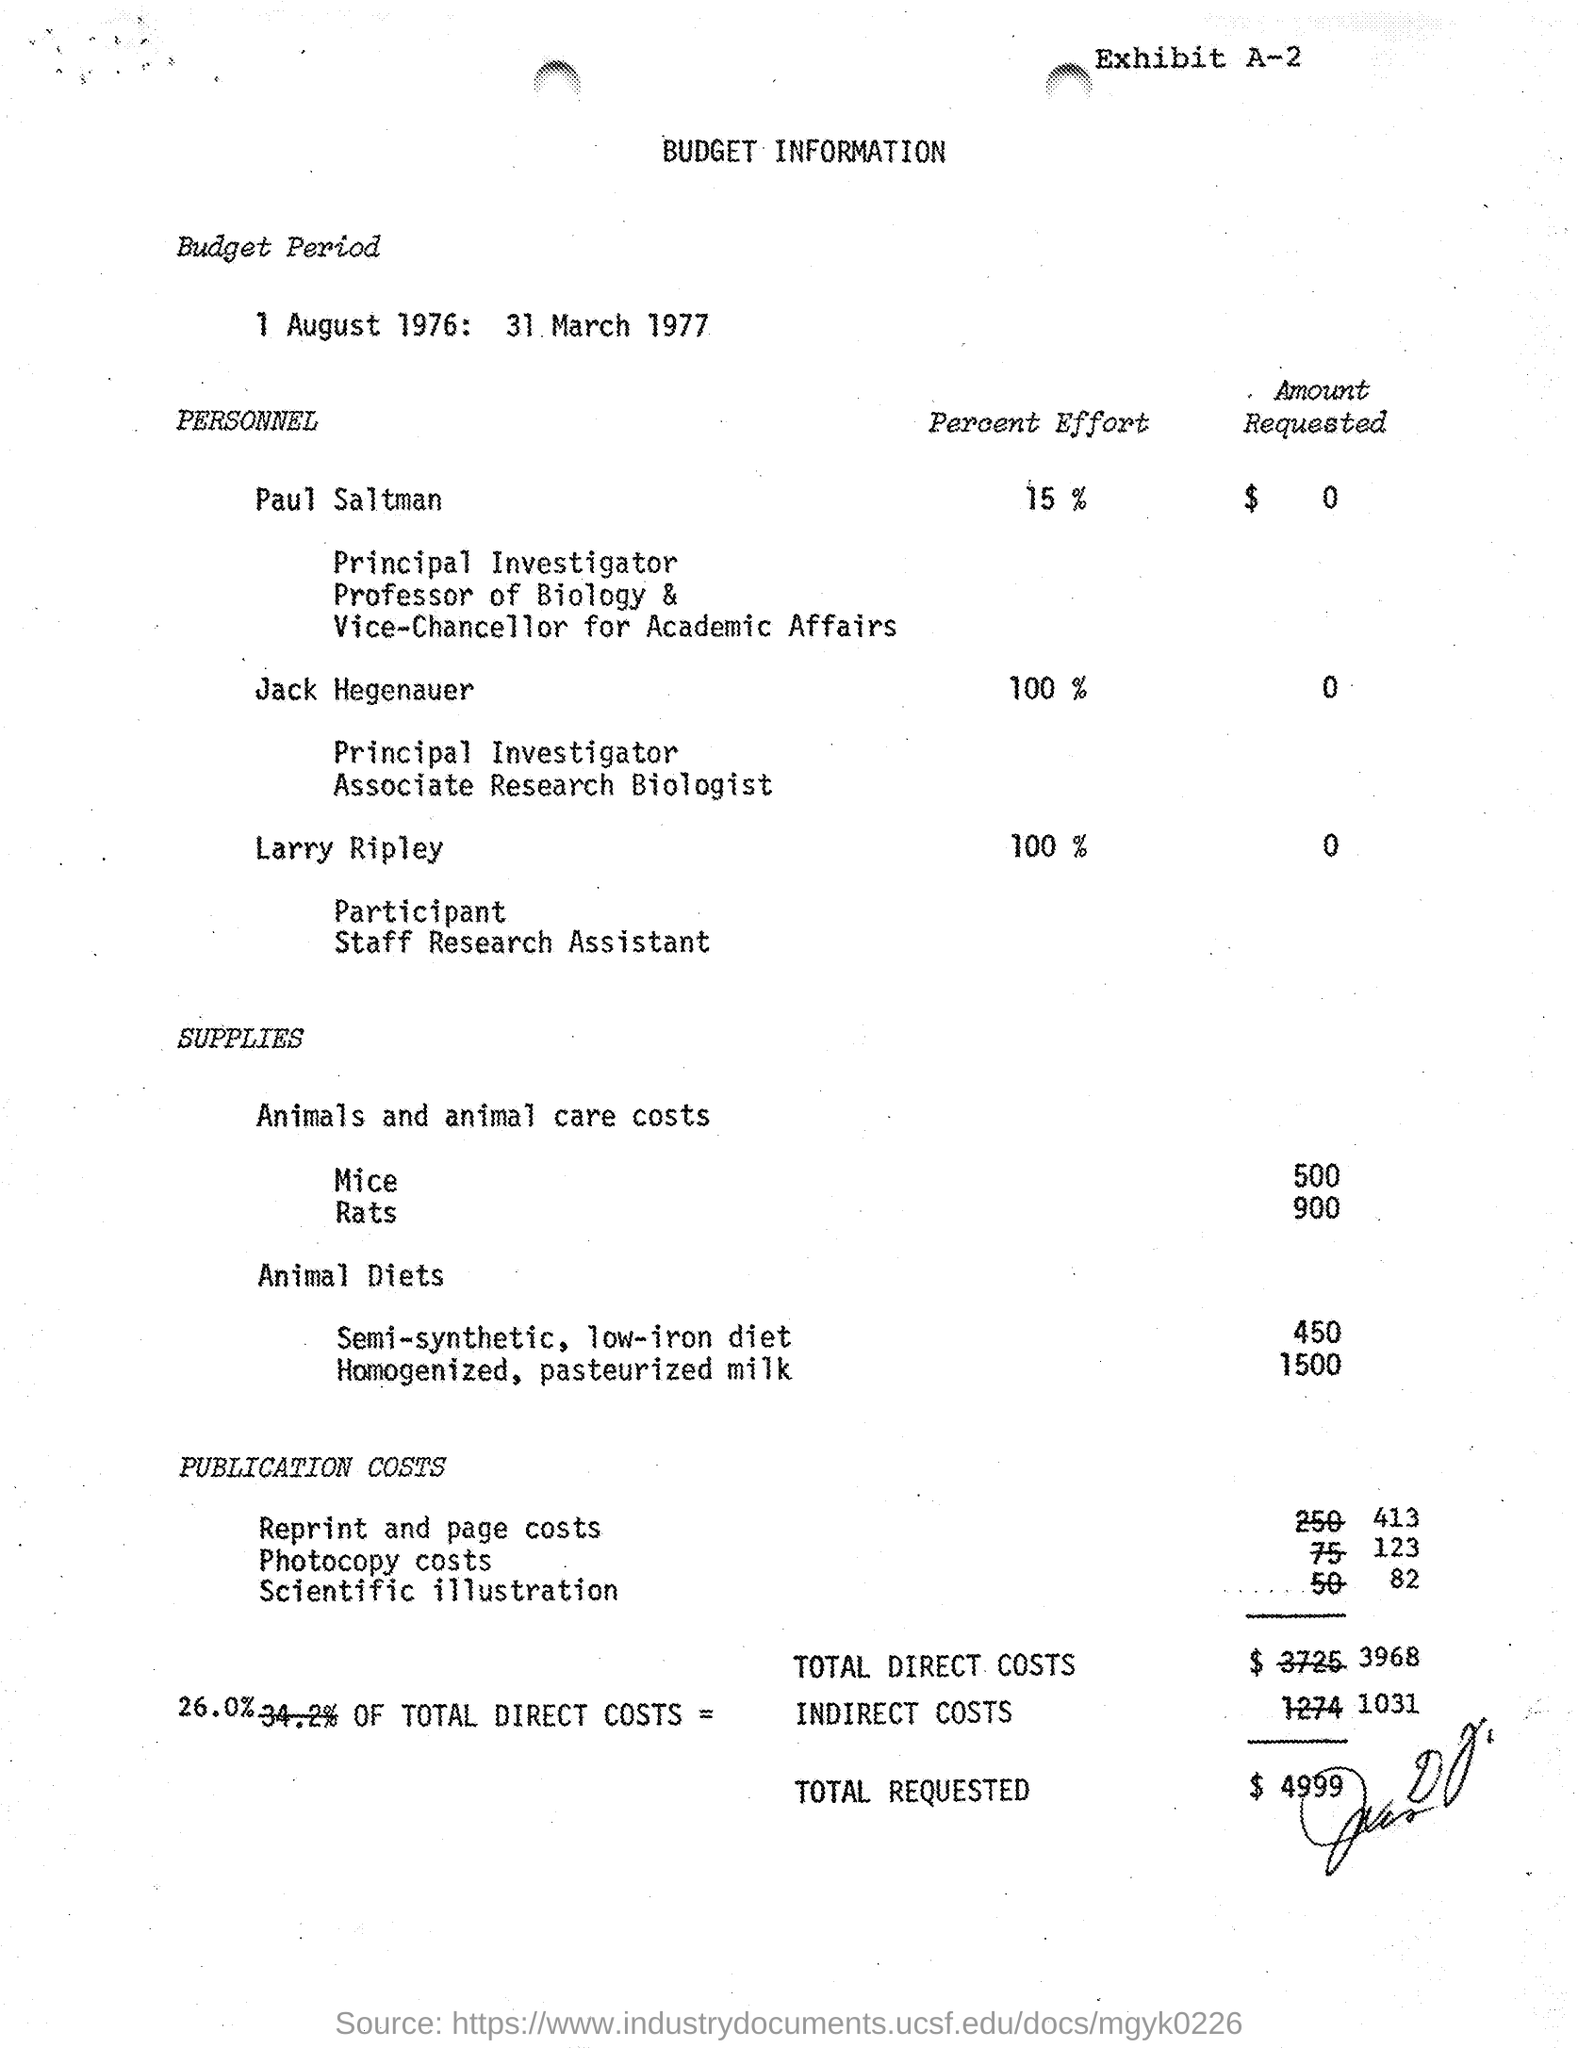List a handful of essential elements in this visual. The Budget Period mentioned in the document is 1 August 1976 to 31 March 1977. Jack Hegenauer is dedicating 100% effort to the project. The total requested budget as stated in the document is $4,999. The total direct costs for the project, as outlined in the provided document, are $3,968. 